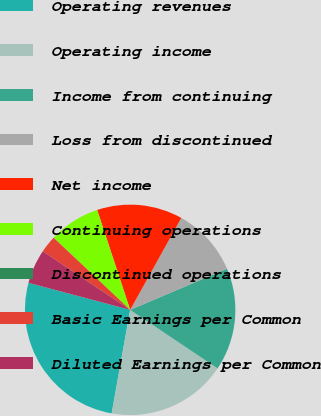<chart> <loc_0><loc_0><loc_500><loc_500><pie_chart><fcel>Operating revenues<fcel>Operating income<fcel>Income from continuing<fcel>Loss from discontinued<fcel>Net income<fcel>Continuing operations<fcel>Discontinued operations<fcel>Basic Earnings per Common<fcel>Diluted Earnings per Common<nl><fcel>26.32%<fcel>18.42%<fcel>15.79%<fcel>10.53%<fcel>13.16%<fcel>7.89%<fcel>0.0%<fcel>2.63%<fcel>5.26%<nl></chart> 